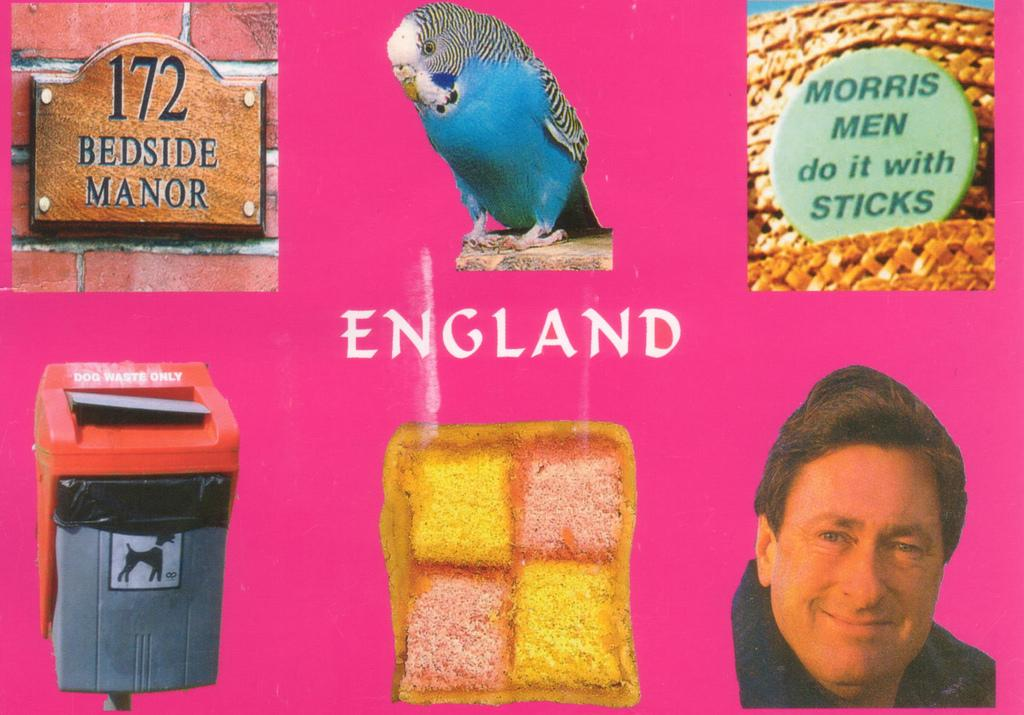What is the main subject of the poster in the image? The poster contains images of a bird, a person, a dustbin, a board, and a food item. Can you describe the images on the poster? The poster contains an image of a bird, a person, a dustbin, a board, and a food item. Is there any text on the poster? Yes, there is a word on the poster. What type of story is being told by the bird and the hall in the image? There is no bird and hall present in the image; the poster contains images of a bird, a person, a dustbin, a board, and a food item. 